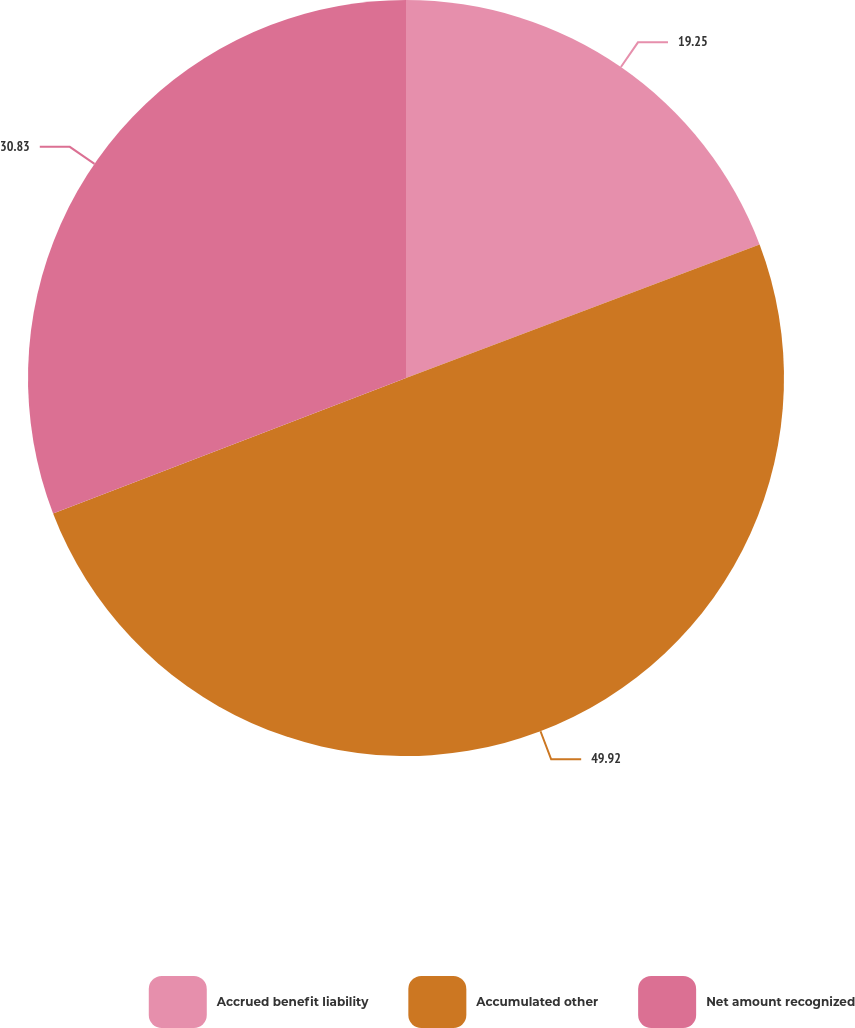Convert chart. <chart><loc_0><loc_0><loc_500><loc_500><pie_chart><fcel>Accrued benefit liability<fcel>Accumulated other<fcel>Net amount recognized<nl><fcel>19.25%<fcel>49.92%<fcel>30.83%<nl></chart> 